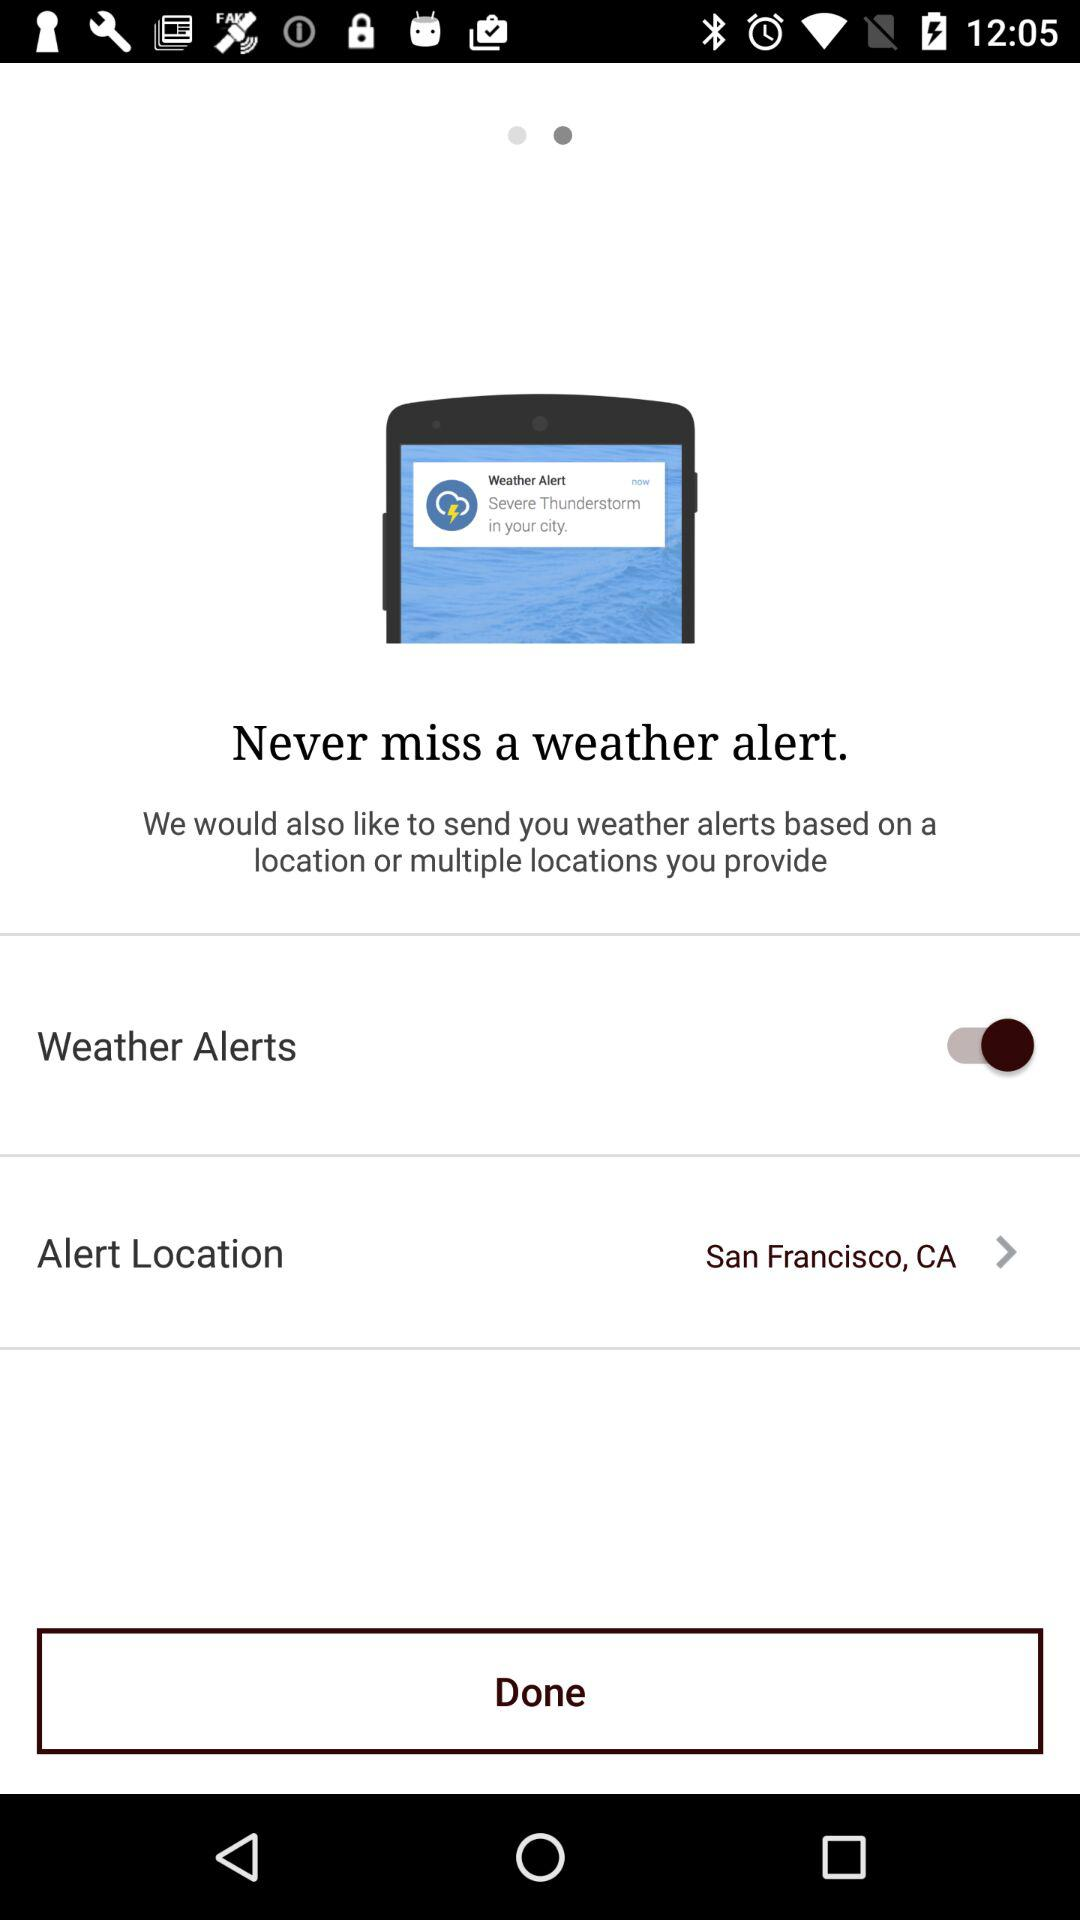What is the status of "Weather Alerts"? The status of "Weather Alerts" is "on". 